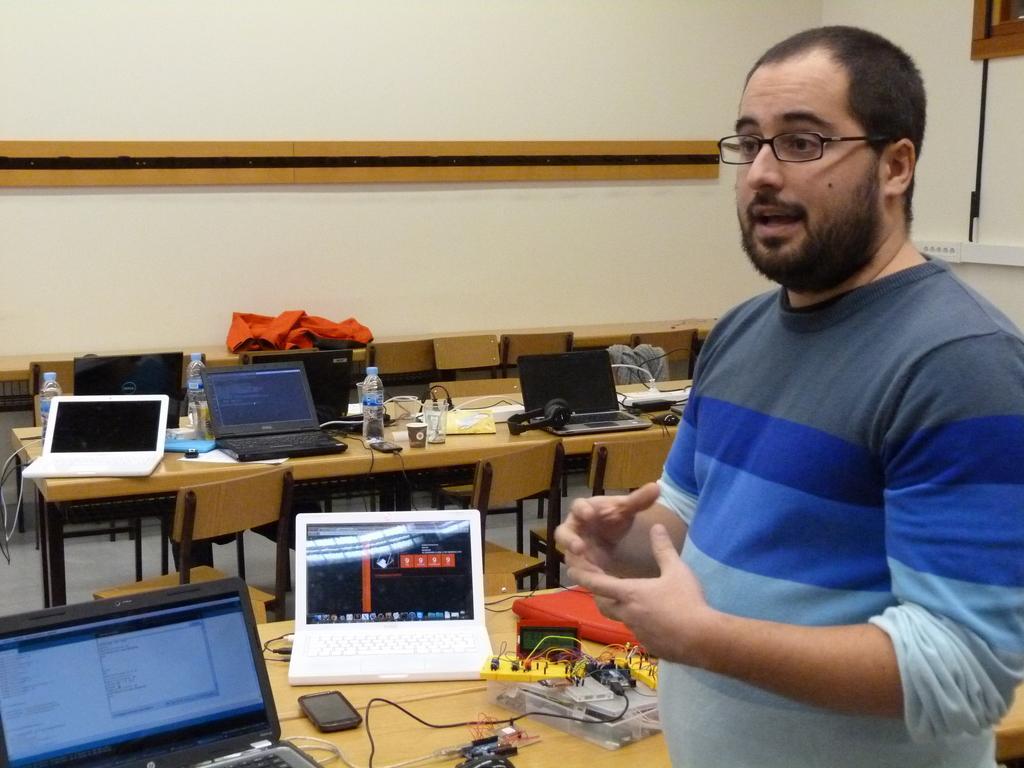In one or two sentences, can you explain what this image depicts? In the image we can see there is a person who is standing and on the table there are laptops, water bottle, mobile phone and other electronic gadgets. 